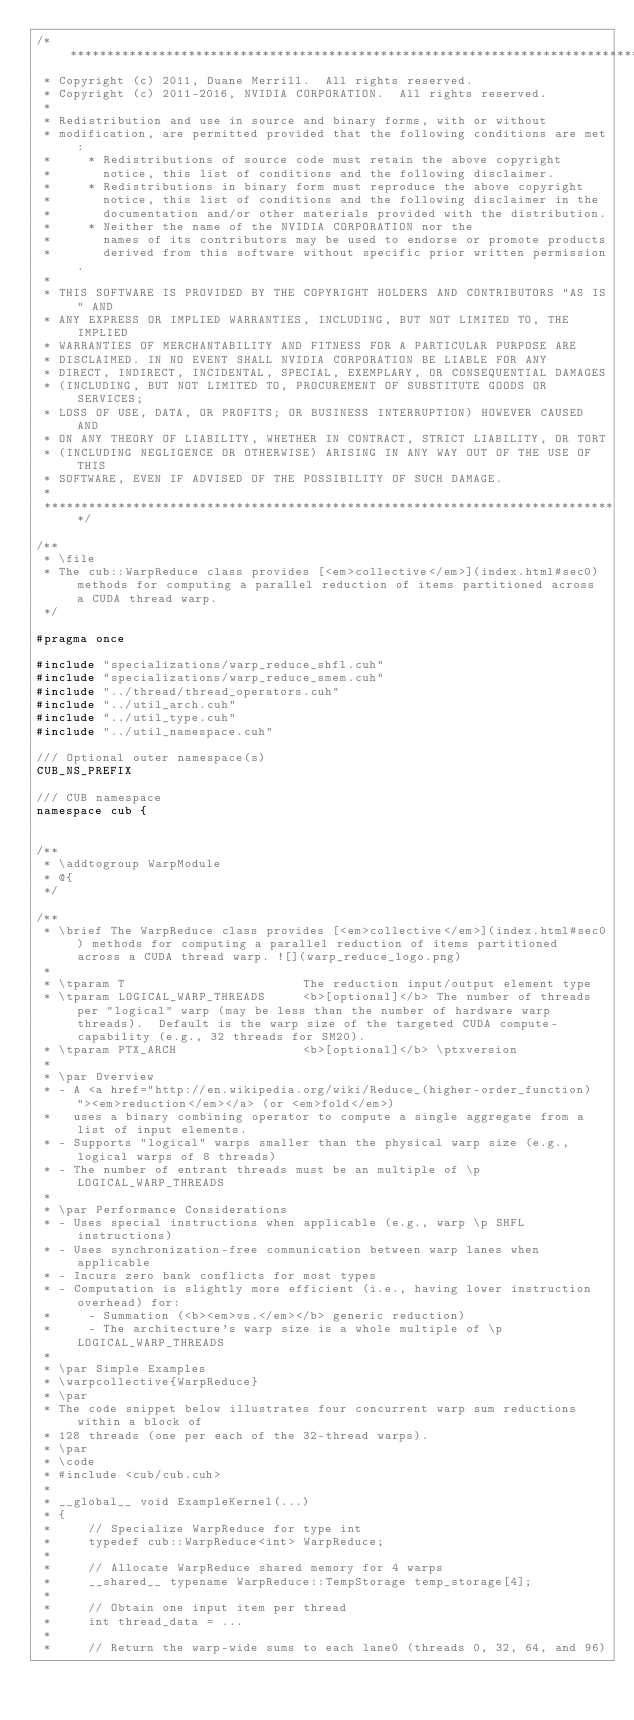Convert code to text. <code><loc_0><loc_0><loc_500><loc_500><_Cuda_>/******************************************************************************
 * Copyright (c) 2011, Duane Merrill.  All rights reserved.
 * Copyright (c) 2011-2016, NVIDIA CORPORATION.  All rights reserved.
 * 
 * Redistribution and use in source and binary forms, with or without
 * modification, are permitted provided that the following conditions are met:
 *     * Redistributions of source code must retain the above copyright
 *       notice, this list of conditions and the following disclaimer.
 *     * Redistributions in binary form must reproduce the above copyright
 *       notice, this list of conditions and the following disclaimer in the
 *       documentation and/or other materials provided with the distribution.
 *     * Neither the name of the NVIDIA CORPORATION nor the
 *       names of its contributors may be used to endorse or promote products
 *       derived from this software without specific prior written permission.
 * 
 * THIS SOFTWARE IS PROVIDED BY THE COPYRIGHT HOLDERS AND CONTRIBUTORS "AS IS" AND
 * ANY EXPRESS OR IMPLIED WARRANTIES, INCLUDING, BUT NOT LIMITED TO, THE IMPLIED
 * WARRANTIES OF MERCHANTABILITY AND FITNESS FOR A PARTICULAR PURPOSE ARE
 * DISCLAIMED. IN NO EVENT SHALL NVIDIA CORPORATION BE LIABLE FOR ANY
 * DIRECT, INDIRECT, INCIDENTAL, SPECIAL, EXEMPLARY, OR CONSEQUENTIAL DAMAGES
 * (INCLUDING, BUT NOT LIMITED TO, PROCUREMENT OF SUBSTITUTE GOODS OR SERVICES;
 * LOSS OF USE, DATA, OR PROFITS; OR BUSINESS INTERRUPTION) HOWEVER CAUSED AND
 * ON ANY THEORY OF LIABILITY, WHETHER IN CONTRACT, STRICT LIABILITY, OR TORT
 * (INCLUDING NEGLIGENCE OR OTHERWISE) ARISING IN ANY WAY OUT OF THE USE OF THIS
 * SOFTWARE, EVEN IF ADVISED OF THE POSSIBILITY OF SUCH DAMAGE.
 *
 ******************************************************************************/

/**
 * \file
 * The cub::WarpReduce class provides [<em>collective</em>](index.html#sec0) methods for computing a parallel reduction of items partitioned across a CUDA thread warp.
 */

#pragma once

#include "specializations/warp_reduce_shfl.cuh"
#include "specializations/warp_reduce_smem.cuh"
#include "../thread/thread_operators.cuh"
#include "../util_arch.cuh"
#include "../util_type.cuh"
#include "../util_namespace.cuh"

/// Optional outer namespace(s)
CUB_NS_PREFIX

/// CUB namespace
namespace cub {


/**
 * \addtogroup WarpModule
 * @{
 */

/**
 * \brief The WarpReduce class provides [<em>collective</em>](index.html#sec0) methods for computing a parallel reduction of items partitioned across a CUDA thread warp. ![](warp_reduce_logo.png)
 *
 * \tparam T                        The reduction input/output element type
 * \tparam LOGICAL_WARP_THREADS     <b>[optional]</b> The number of threads per "logical" warp (may be less than the number of hardware warp threads).  Default is the warp size of the targeted CUDA compute-capability (e.g., 32 threads for SM20).
 * \tparam PTX_ARCH                 <b>[optional]</b> \ptxversion
 *
 * \par Overview
 * - A <a href="http://en.wikipedia.org/wiki/Reduce_(higher-order_function)"><em>reduction</em></a> (or <em>fold</em>)
 *   uses a binary combining operator to compute a single aggregate from a list of input elements.
 * - Supports "logical" warps smaller than the physical warp size (e.g., logical warps of 8 threads)
 * - The number of entrant threads must be an multiple of \p LOGICAL_WARP_THREADS
 *
 * \par Performance Considerations
 * - Uses special instructions when applicable (e.g., warp \p SHFL instructions)
 * - Uses synchronization-free communication between warp lanes when applicable
 * - Incurs zero bank conflicts for most types
 * - Computation is slightly more efficient (i.e., having lower instruction overhead) for:
 *     - Summation (<b><em>vs.</em></b> generic reduction)
 *     - The architecture's warp size is a whole multiple of \p LOGICAL_WARP_THREADS
 *
 * \par Simple Examples
 * \warpcollective{WarpReduce}
 * \par
 * The code snippet below illustrates four concurrent warp sum reductions within a block of
 * 128 threads (one per each of the 32-thread warps).
 * \par
 * \code
 * #include <cub/cub.cuh>
 *
 * __global__ void ExampleKernel(...)
 * {
 *     // Specialize WarpReduce for type int
 *     typedef cub::WarpReduce<int> WarpReduce;
 *
 *     // Allocate WarpReduce shared memory for 4 warps
 *     __shared__ typename WarpReduce::TempStorage temp_storage[4];
 *
 *     // Obtain one input item per thread
 *     int thread_data = ...
 *
 *     // Return the warp-wide sums to each lane0 (threads 0, 32, 64, and 96)</code> 